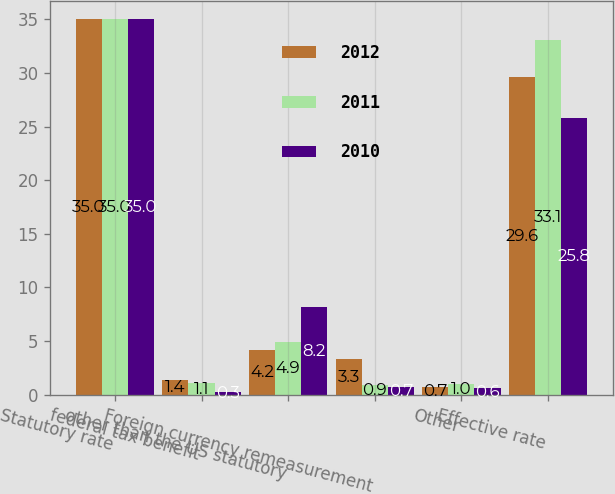Convert chart to OTSL. <chart><loc_0><loc_0><loc_500><loc_500><stacked_bar_chart><ecel><fcel>Statutory rate<fcel>federal tax benefit<fcel>other than the US statutory<fcel>Foreign currency remeasurement<fcel>Other<fcel>Effective rate<nl><fcel>2012<fcel>35<fcel>1.4<fcel>4.2<fcel>3.3<fcel>0.7<fcel>29.6<nl><fcel>2011<fcel>35<fcel>1.1<fcel>4.9<fcel>0.9<fcel>1<fcel>33.1<nl><fcel>2010<fcel>35<fcel>0.3<fcel>8.2<fcel>0.7<fcel>0.6<fcel>25.8<nl></chart> 